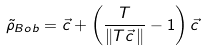Convert formula to latex. <formula><loc_0><loc_0><loc_500><loc_500>\tilde { \rho } _ { B o b } = \vec { c } + \left ( \frac { T } { \| T \vec { c } \, \| } - 1 \right ) \vec { c }</formula> 